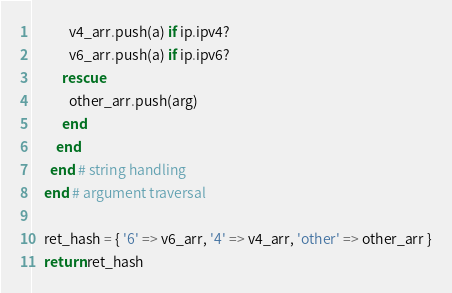<code> <loc_0><loc_0><loc_500><loc_500><_Ruby_>            v4_arr.push(a) if ip.ipv4?
            v6_arr.push(a) if ip.ipv6?
          rescue
            other_arr.push(arg)
          end
        end
      end # string handling
    end # argument traversal

    ret_hash = { '6' => v6_arr, '4' => v4_arr, 'other' => other_arr }
    return ret_hash</code> 